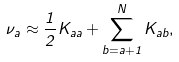<formula> <loc_0><loc_0><loc_500><loc_500>\nu _ { a } \approx \frac { 1 } { 2 } K _ { a a } + \sum _ { b = a + 1 } ^ { N } K _ { a b } ,</formula> 